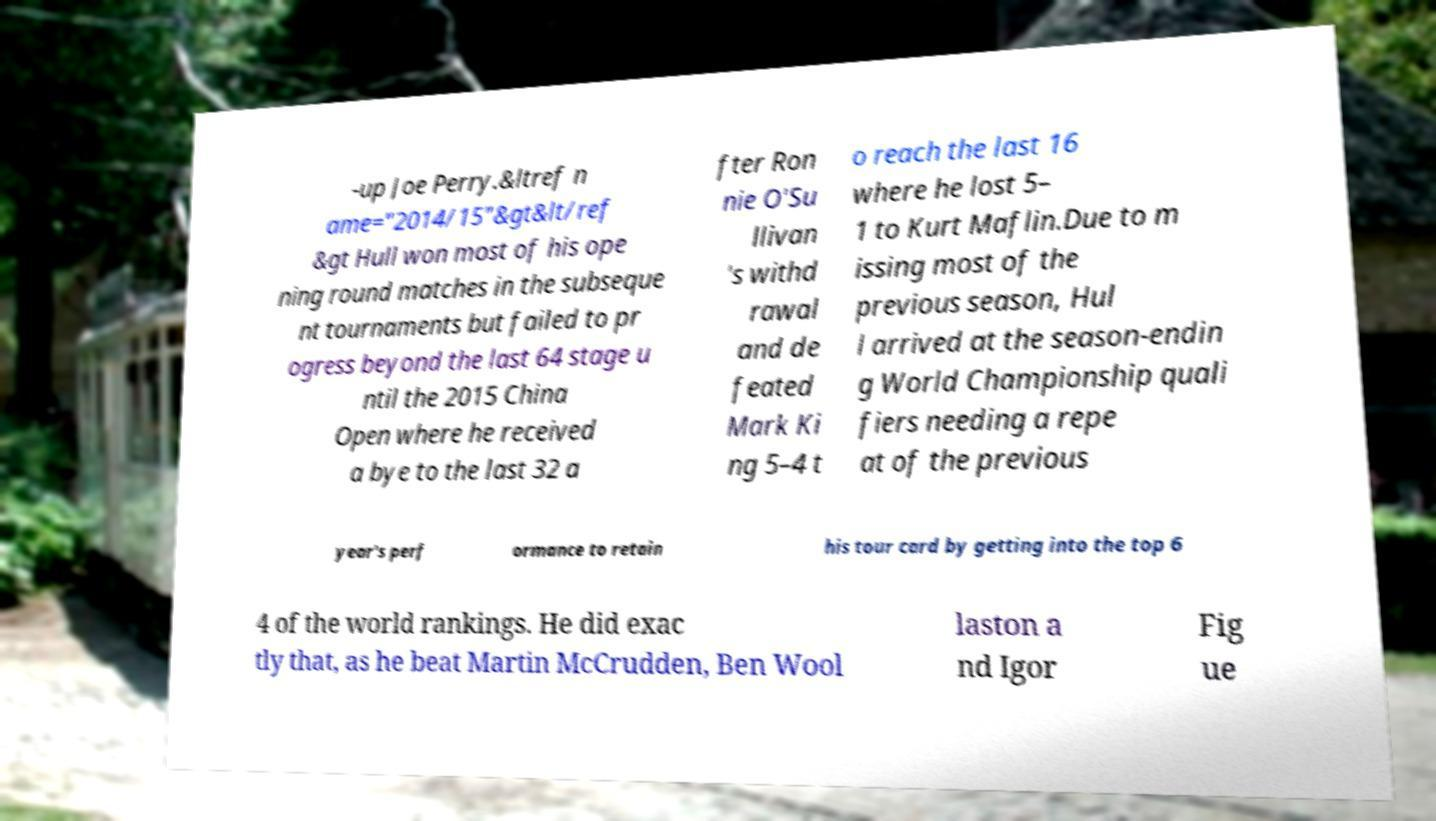There's text embedded in this image that I need extracted. Can you transcribe it verbatim? -up Joe Perry.&ltref n ame="2014/15"&gt&lt/ref &gt Hull won most of his ope ning round matches in the subseque nt tournaments but failed to pr ogress beyond the last 64 stage u ntil the 2015 China Open where he received a bye to the last 32 a fter Ron nie O'Su llivan 's withd rawal and de feated Mark Ki ng 5–4 t o reach the last 16 where he lost 5– 1 to Kurt Maflin.Due to m issing most of the previous season, Hul l arrived at the season-endin g World Championship quali fiers needing a repe at of the previous year's perf ormance to retain his tour card by getting into the top 6 4 of the world rankings. He did exac tly that, as he beat Martin McCrudden, Ben Wool laston a nd Igor Fig ue 